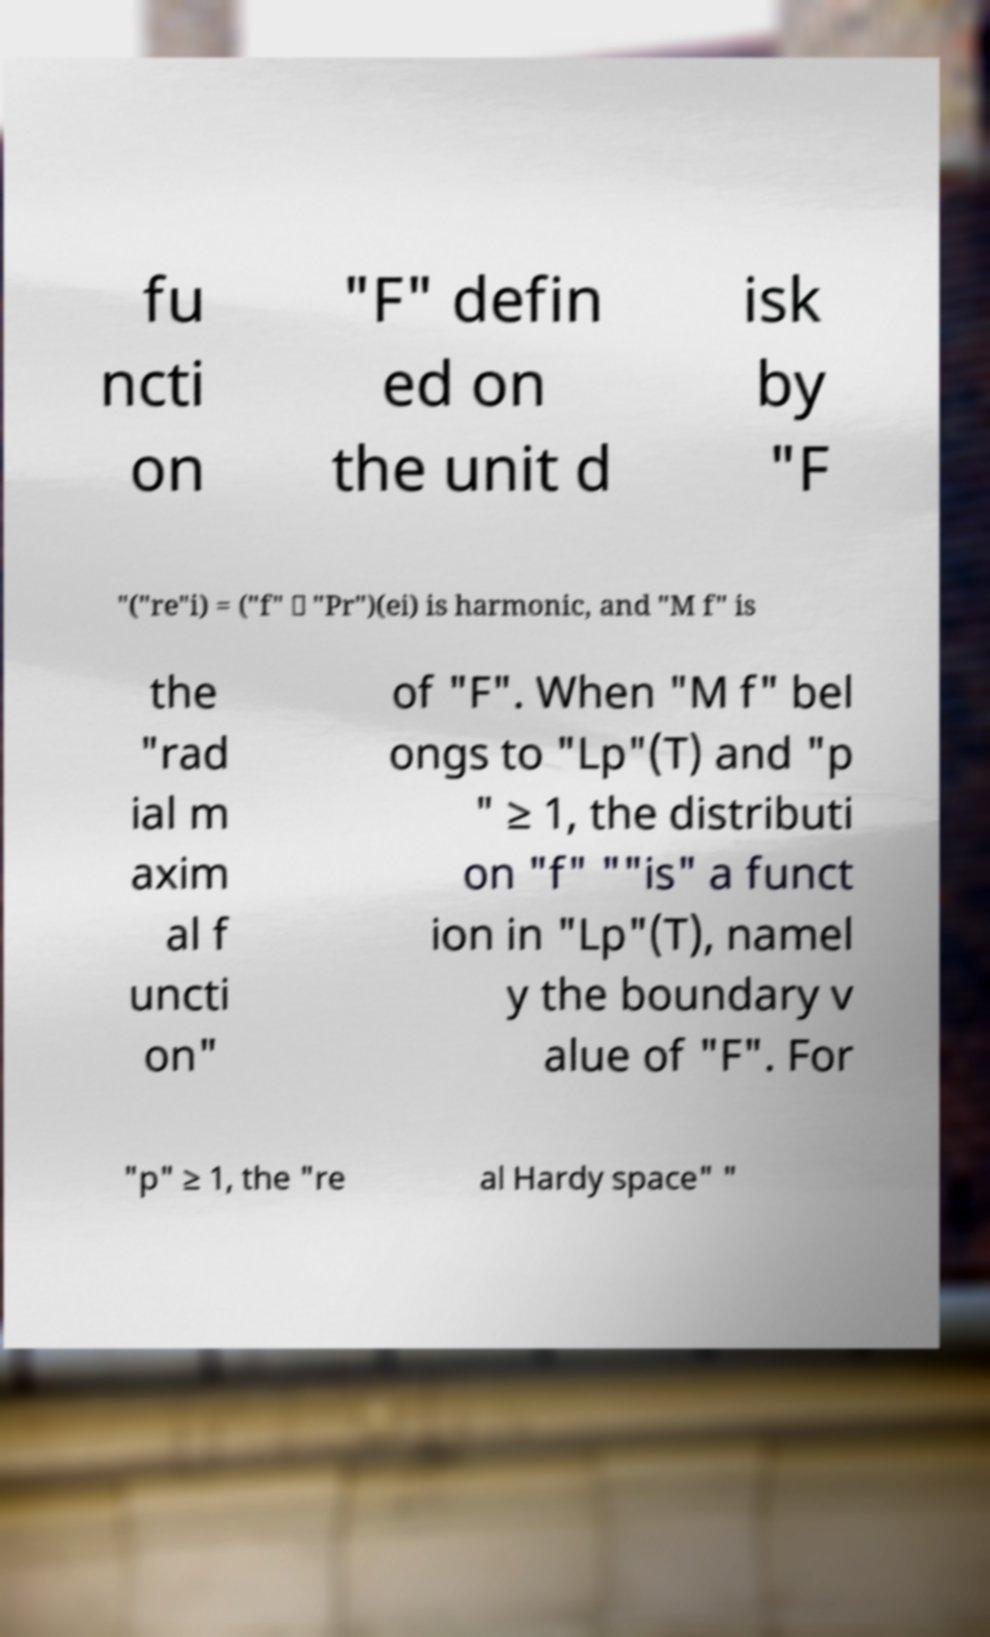Can you read and provide the text displayed in the image?This photo seems to have some interesting text. Can you extract and type it out for me? fu ncti on "F" defin ed on the unit d isk by "F "("re"i) = ("f" ∗ "Pr")(ei) is harmonic, and "M f" is the "rad ial m axim al f uncti on" of "F". When "M f" bel ongs to "Lp"(T) and "p " ≥ 1, the distributi on "f" ""is" a funct ion in "Lp"(T), namel y the boundary v alue of "F". For "p" ≥ 1, the "re al Hardy space" " 